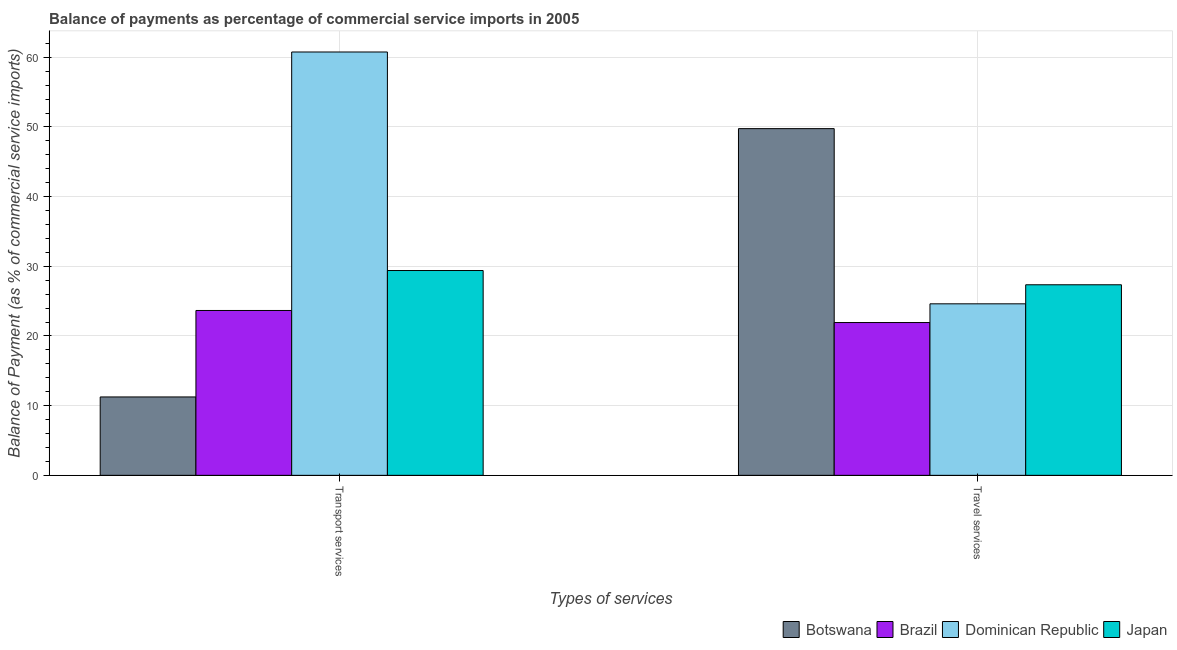How many different coloured bars are there?
Offer a terse response. 4. How many groups of bars are there?
Ensure brevity in your answer.  2. How many bars are there on the 2nd tick from the left?
Your answer should be compact. 4. What is the label of the 2nd group of bars from the left?
Give a very brief answer. Travel services. What is the balance of payments of transport services in Brazil?
Give a very brief answer. 23.66. Across all countries, what is the maximum balance of payments of travel services?
Your response must be concise. 49.76. Across all countries, what is the minimum balance of payments of travel services?
Offer a terse response. 21.93. In which country was the balance of payments of travel services maximum?
Keep it short and to the point. Botswana. In which country was the balance of payments of transport services minimum?
Ensure brevity in your answer.  Botswana. What is the total balance of payments of travel services in the graph?
Offer a very short reply. 123.65. What is the difference between the balance of payments of transport services in Japan and that in Brazil?
Your answer should be compact. 5.73. What is the difference between the balance of payments of travel services in Botswana and the balance of payments of transport services in Dominican Republic?
Your answer should be compact. -11. What is the average balance of payments of transport services per country?
Your response must be concise. 31.27. What is the difference between the balance of payments of transport services and balance of payments of travel services in Botswana?
Offer a terse response. -38.51. In how many countries, is the balance of payments of travel services greater than 4 %?
Make the answer very short. 4. What is the ratio of the balance of payments of travel services in Botswana to that in Dominican Republic?
Your response must be concise. 2.02. Is the balance of payments of transport services in Botswana less than that in Brazil?
Ensure brevity in your answer.  Yes. In how many countries, is the balance of payments of transport services greater than the average balance of payments of transport services taken over all countries?
Your response must be concise. 1. What does the 1st bar from the left in Transport services represents?
Give a very brief answer. Botswana. What does the 2nd bar from the right in Transport services represents?
Give a very brief answer. Dominican Republic. Are all the bars in the graph horizontal?
Keep it short and to the point. No. How many countries are there in the graph?
Your answer should be compact. 4. What is the difference between two consecutive major ticks on the Y-axis?
Your response must be concise. 10. Does the graph contain any zero values?
Offer a very short reply. No. Does the graph contain grids?
Offer a terse response. Yes. What is the title of the graph?
Offer a terse response. Balance of payments as percentage of commercial service imports in 2005. Does "Netherlands" appear as one of the legend labels in the graph?
Your answer should be very brief. No. What is the label or title of the X-axis?
Offer a terse response. Types of services. What is the label or title of the Y-axis?
Offer a very short reply. Balance of Payment (as % of commercial service imports). What is the Balance of Payment (as % of commercial service imports) of Botswana in Transport services?
Your response must be concise. 11.25. What is the Balance of Payment (as % of commercial service imports) of Brazil in Transport services?
Provide a succinct answer. 23.66. What is the Balance of Payment (as % of commercial service imports) of Dominican Republic in Transport services?
Keep it short and to the point. 60.76. What is the Balance of Payment (as % of commercial service imports) of Japan in Transport services?
Make the answer very short. 29.4. What is the Balance of Payment (as % of commercial service imports) in Botswana in Travel services?
Offer a very short reply. 49.76. What is the Balance of Payment (as % of commercial service imports) in Brazil in Travel services?
Keep it short and to the point. 21.93. What is the Balance of Payment (as % of commercial service imports) in Dominican Republic in Travel services?
Your response must be concise. 24.62. What is the Balance of Payment (as % of commercial service imports) of Japan in Travel services?
Your answer should be compact. 27.35. Across all Types of services, what is the maximum Balance of Payment (as % of commercial service imports) of Botswana?
Keep it short and to the point. 49.76. Across all Types of services, what is the maximum Balance of Payment (as % of commercial service imports) of Brazil?
Your answer should be compact. 23.66. Across all Types of services, what is the maximum Balance of Payment (as % of commercial service imports) in Dominican Republic?
Offer a terse response. 60.76. Across all Types of services, what is the maximum Balance of Payment (as % of commercial service imports) in Japan?
Offer a very short reply. 29.4. Across all Types of services, what is the minimum Balance of Payment (as % of commercial service imports) in Botswana?
Your answer should be compact. 11.25. Across all Types of services, what is the minimum Balance of Payment (as % of commercial service imports) in Brazil?
Provide a succinct answer. 21.93. Across all Types of services, what is the minimum Balance of Payment (as % of commercial service imports) in Dominican Republic?
Offer a terse response. 24.62. Across all Types of services, what is the minimum Balance of Payment (as % of commercial service imports) in Japan?
Your answer should be compact. 27.35. What is the total Balance of Payment (as % of commercial service imports) in Botswana in the graph?
Give a very brief answer. 61.01. What is the total Balance of Payment (as % of commercial service imports) of Brazil in the graph?
Offer a very short reply. 45.59. What is the total Balance of Payment (as % of commercial service imports) of Dominican Republic in the graph?
Your answer should be compact. 85.37. What is the total Balance of Payment (as % of commercial service imports) in Japan in the graph?
Your response must be concise. 56.74. What is the difference between the Balance of Payment (as % of commercial service imports) of Botswana in Transport services and that in Travel services?
Your answer should be very brief. -38.51. What is the difference between the Balance of Payment (as % of commercial service imports) in Brazil in Transport services and that in Travel services?
Give a very brief answer. 1.73. What is the difference between the Balance of Payment (as % of commercial service imports) of Dominican Republic in Transport services and that in Travel services?
Provide a short and direct response. 36.14. What is the difference between the Balance of Payment (as % of commercial service imports) in Japan in Transport services and that in Travel services?
Your response must be concise. 2.05. What is the difference between the Balance of Payment (as % of commercial service imports) of Botswana in Transport services and the Balance of Payment (as % of commercial service imports) of Brazil in Travel services?
Offer a very short reply. -10.68. What is the difference between the Balance of Payment (as % of commercial service imports) of Botswana in Transport services and the Balance of Payment (as % of commercial service imports) of Dominican Republic in Travel services?
Offer a very short reply. -13.36. What is the difference between the Balance of Payment (as % of commercial service imports) in Botswana in Transport services and the Balance of Payment (as % of commercial service imports) in Japan in Travel services?
Offer a very short reply. -16.1. What is the difference between the Balance of Payment (as % of commercial service imports) in Brazil in Transport services and the Balance of Payment (as % of commercial service imports) in Dominican Republic in Travel services?
Offer a terse response. -0.96. What is the difference between the Balance of Payment (as % of commercial service imports) in Brazil in Transport services and the Balance of Payment (as % of commercial service imports) in Japan in Travel services?
Ensure brevity in your answer.  -3.69. What is the difference between the Balance of Payment (as % of commercial service imports) in Dominican Republic in Transport services and the Balance of Payment (as % of commercial service imports) in Japan in Travel services?
Your response must be concise. 33.41. What is the average Balance of Payment (as % of commercial service imports) of Botswana per Types of services?
Offer a very short reply. 30.5. What is the average Balance of Payment (as % of commercial service imports) of Brazil per Types of services?
Your answer should be compact. 22.79. What is the average Balance of Payment (as % of commercial service imports) in Dominican Republic per Types of services?
Offer a very short reply. 42.69. What is the average Balance of Payment (as % of commercial service imports) in Japan per Types of services?
Your answer should be compact. 28.37. What is the difference between the Balance of Payment (as % of commercial service imports) of Botswana and Balance of Payment (as % of commercial service imports) of Brazil in Transport services?
Ensure brevity in your answer.  -12.41. What is the difference between the Balance of Payment (as % of commercial service imports) in Botswana and Balance of Payment (as % of commercial service imports) in Dominican Republic in Transport services?
Provide a succinct answer. -49.51. What is the difference between the Balance of Payment (as % of commercial service imports) of Botswana and Balance of Payment (as % of commercial service imports) of Japan in Transport services?
Ensure brevity in your answer.  -18.14. What is the difference between the Balance of Payment (as % of commercial service imports) of Brazil and Balance of Payment (as % of commercial service imports) of Dominican Republic in Transport services?
Provide a succinct answer. -37.1. What is the difference between the Balance of Payment (as % of commercial service imports) in Brazil and Balance of Payment (as % of commercial service imports) in Japan in Transport services?
Ensure brevity in your answer.  -5.74. What is the difference between the Balance of Payment (as % of commercial service imports) in Dominican Republic and Balance of Payment (as % of commercial service imports) in Japan in Transport services?
Make the answer very short. 31.36. What is the difference between the Balance of Payment (as % of commercial service imports) in Botswana and Balance of Payment (as % of commercial service imports) in Brazil in Travel services?
Offer a terse response. 27.83. What is the difference between the Balance of Payment (as % of commercial service imports) of Botswana and Balance of Payment (as % of commercial service imports) of Dominican Republic in Travel services?
Your answer should be very brief. 25.14. What is the difference between the Balance of Payment (as % of commercial service imports) of Botswana and Balance of Payment (as % of commercial service imports) of Japan in Travel services?
Offer a terse response. 22.41. What is the difference between the Balance of Payment (as % of commercial service imports) of Brazil and Balance of Payment (as % of commercial service imports) of Dominican Republic in Travel services?
Keep it short and to the point. -2.69. What is the difference between the Balance of Payment (as % of commercial service imports) in Brazil and Balance of Payment (as % of commercial service imports) in Japan in Travel services?
Your answer should be compact. -5.42. What is the difference between the Balance of Payment (as % of commercial service imports) in Dominican Republic and Balance of Payment (as % of commercial service imports) in Japan in Travel services?
Your response must be concise. -2.73. What is the ratio of the Balance of Payment (as % of commercial service imports) of Botswana in Transport services to that in Travel services?
Provide a short and direct response. 0.23. What is the ratio of the Balance of Payment (as % of commercial service imports) of Brazil in Transport services to that in Travel services?
Your answer should be compact. 1.08. What is the ratio of the Balance of Payment (as % of commercial service imports) in Dominican Republic in Transport services to that in Travel services?
Your answer should be very brief. 2.47. What is the ratio of the Balance of Payment (as % of commercial service imports) in Japan in Transport services to that in Travel services?
Offer a very short reply. 1.07. What is the difference between the highest and the second highest Balance of Payment (as % of commercial service imports) in Botswana?
Offer a terse response. 38.51. What is the difference between the highest and the second highest Balance of Payment (as % of commercial service imports) in Brazil?
Make the answer very short. 1.73. What is the difference between the highest and the second highest Balance of Payment (as % of commercial service imports) of Dominican Republic?
Offer a very short reply. 36.14. What is the difference between the highest and the second highest Balance of Payment (as % of commercial service imports) of Japan?
Ensure brevity in your answer.  2.05. What is the difference between the highest and the lowest Balance of Payment (as % of commercial service imports) in Botswana?
Give a very brief answer. 38.51. What is the difference between the highest and the lowest Balance of Payment (as % of commercial service imports) of Brazil?
Your answer should be compact. 1.73. What is the difference between the highest and the lowest Balance of Payment (as % of commercial service imports) of Dominican Republic?
Give a very brief answer. 36.14. What is the difference between the highest and the lowest Balance of Payment (as % of commercial service imports) of Japan?
Keep it short and to the point. 2.05. 